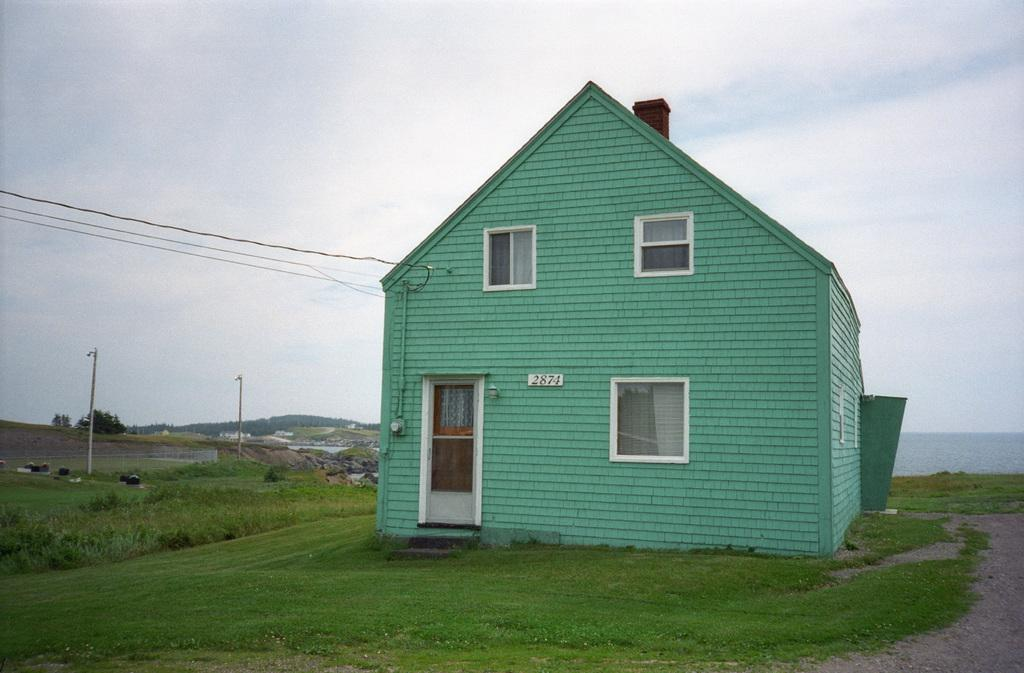What type of structure is present in the image? There is a shelter house in the image. What color is the shelter house? The shelter house is green. What can be seen on the left side of the image? There are poles on the left side of the image. What is visible in the background of the image? There is a sky visible in the background of the image. How many mice are sitting on the roof of the shelter house in the image? There are no mice present in the image; it only features a green shelter house and poles on the left side. 